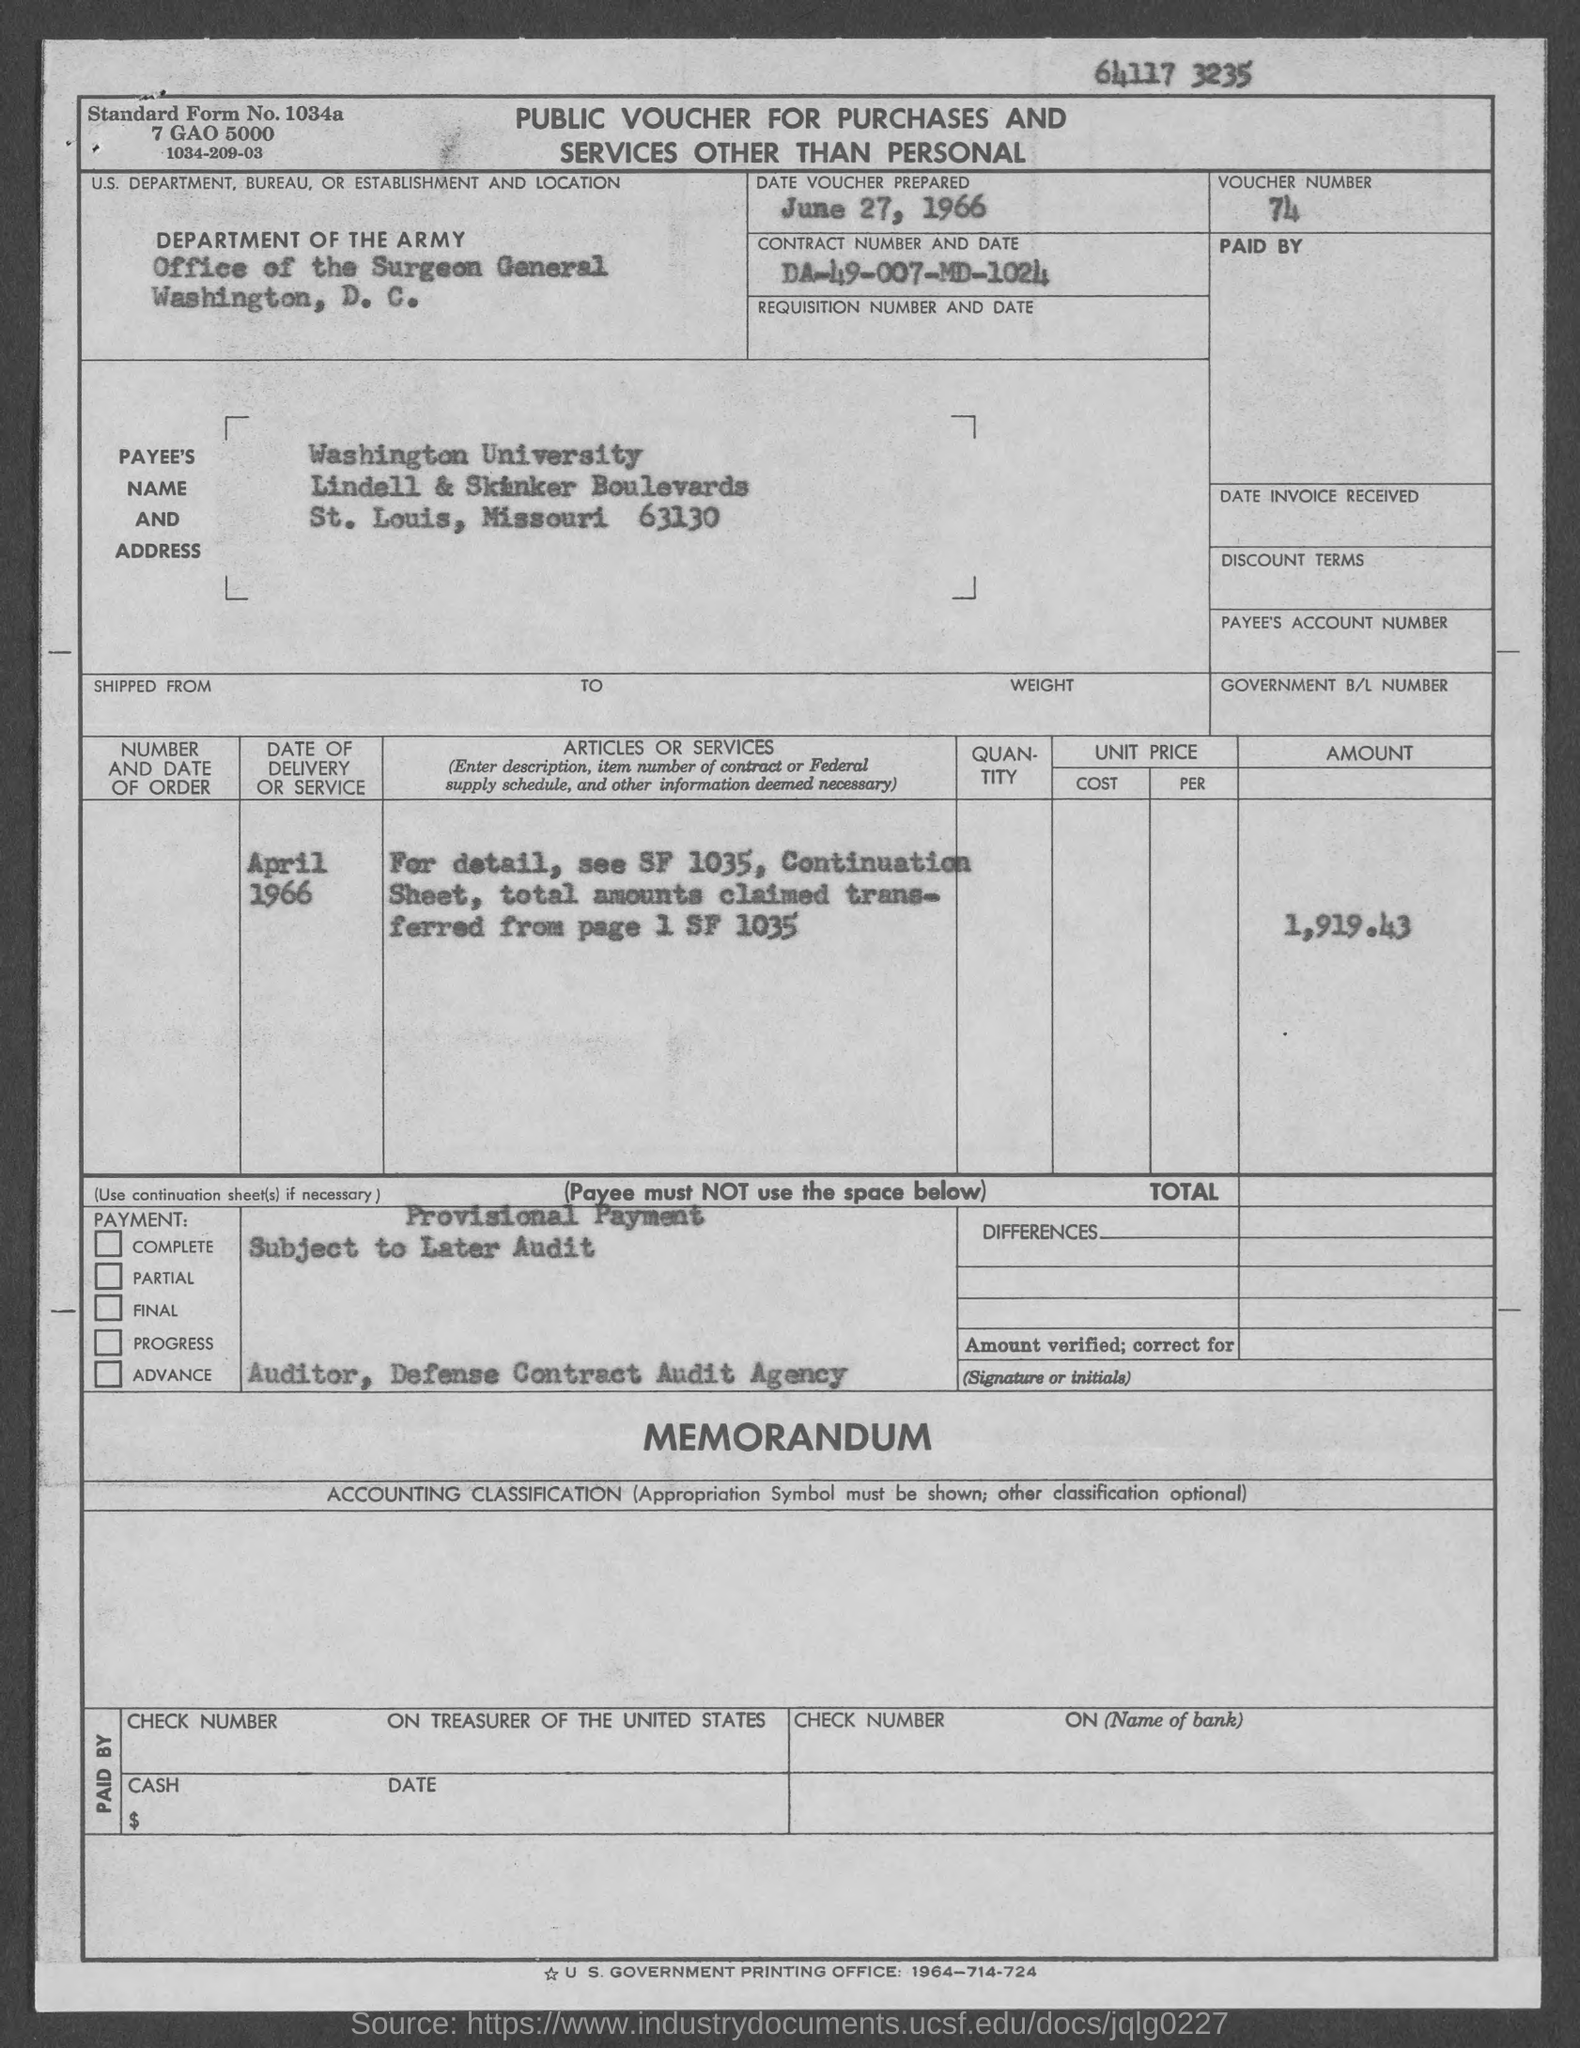Identify some key points in this picture. The contract number is DA-49-007-MD-1024. Here is the voucher number: 74. What is the standard form no.? 1034a...." is a question asking for information about a standard form number. The date of delivery or service is April 1966. The Department of the Army is the U.S. department responsible for the management and operation of the Army. 